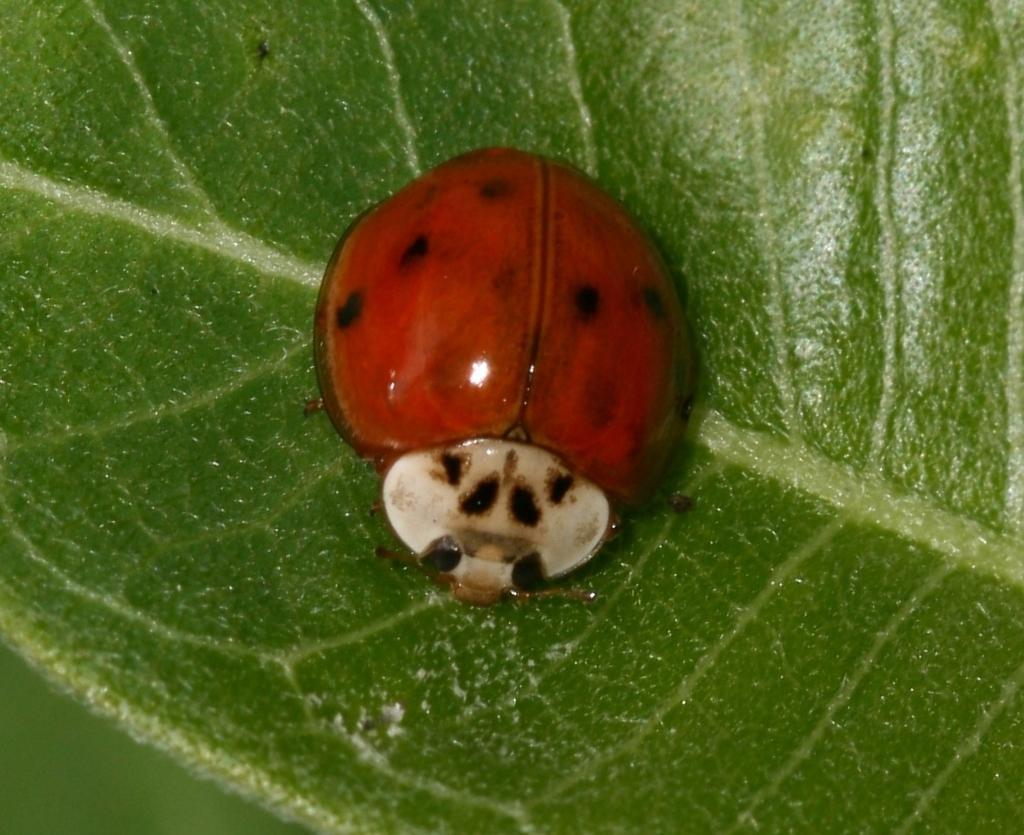Describe this image in one or two sentences. In this image I can see there is an insect in orange color on a leaf. 